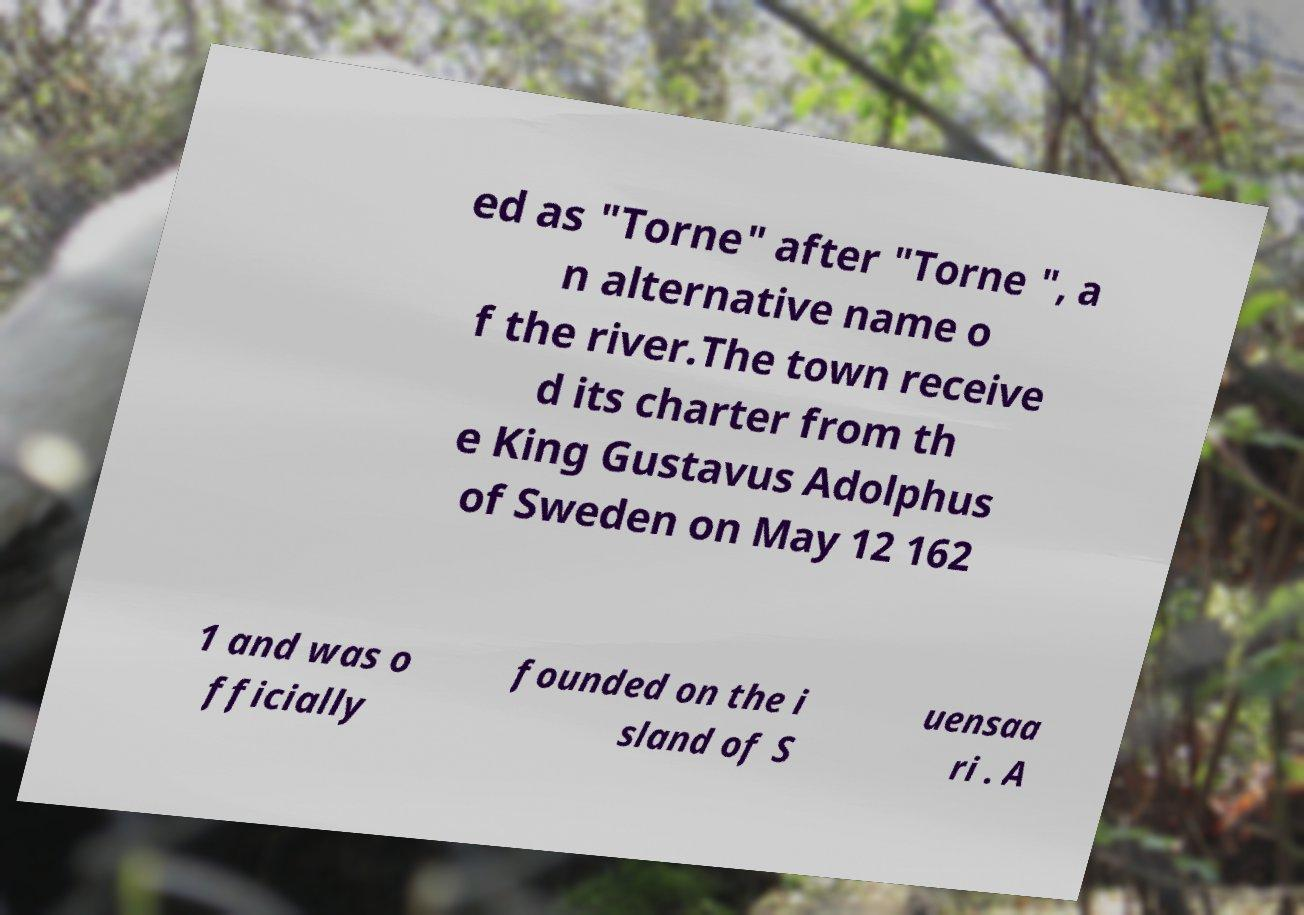What messages or text are displayed in this image? I need them in a readable, typed format. ed as "Torne" after "Torne ", a n alternative name o f the river.The town receive d its charter from th e King Gustavus Adolphus of Sweden on May 12 162 1 and was o fficially founded on the i sland of S uensaa ri . A 